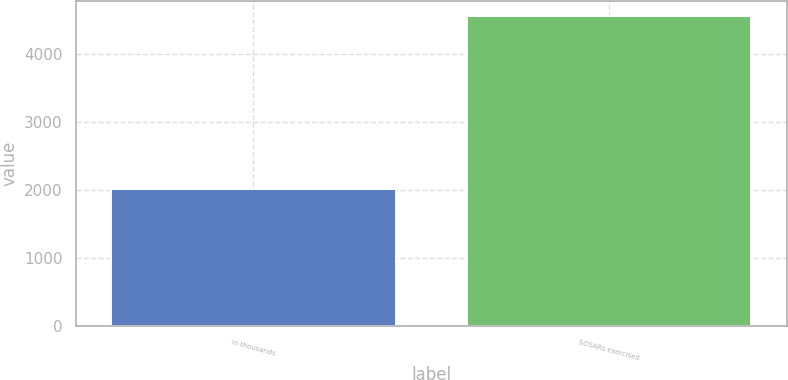<chart> <loc_0><loc_0><loc_500><loc_500><bar_chart><fcel>in thousands<fcel>SOSARs exercised<nl><fcel>2013<fcel>4563<nl></chart> 